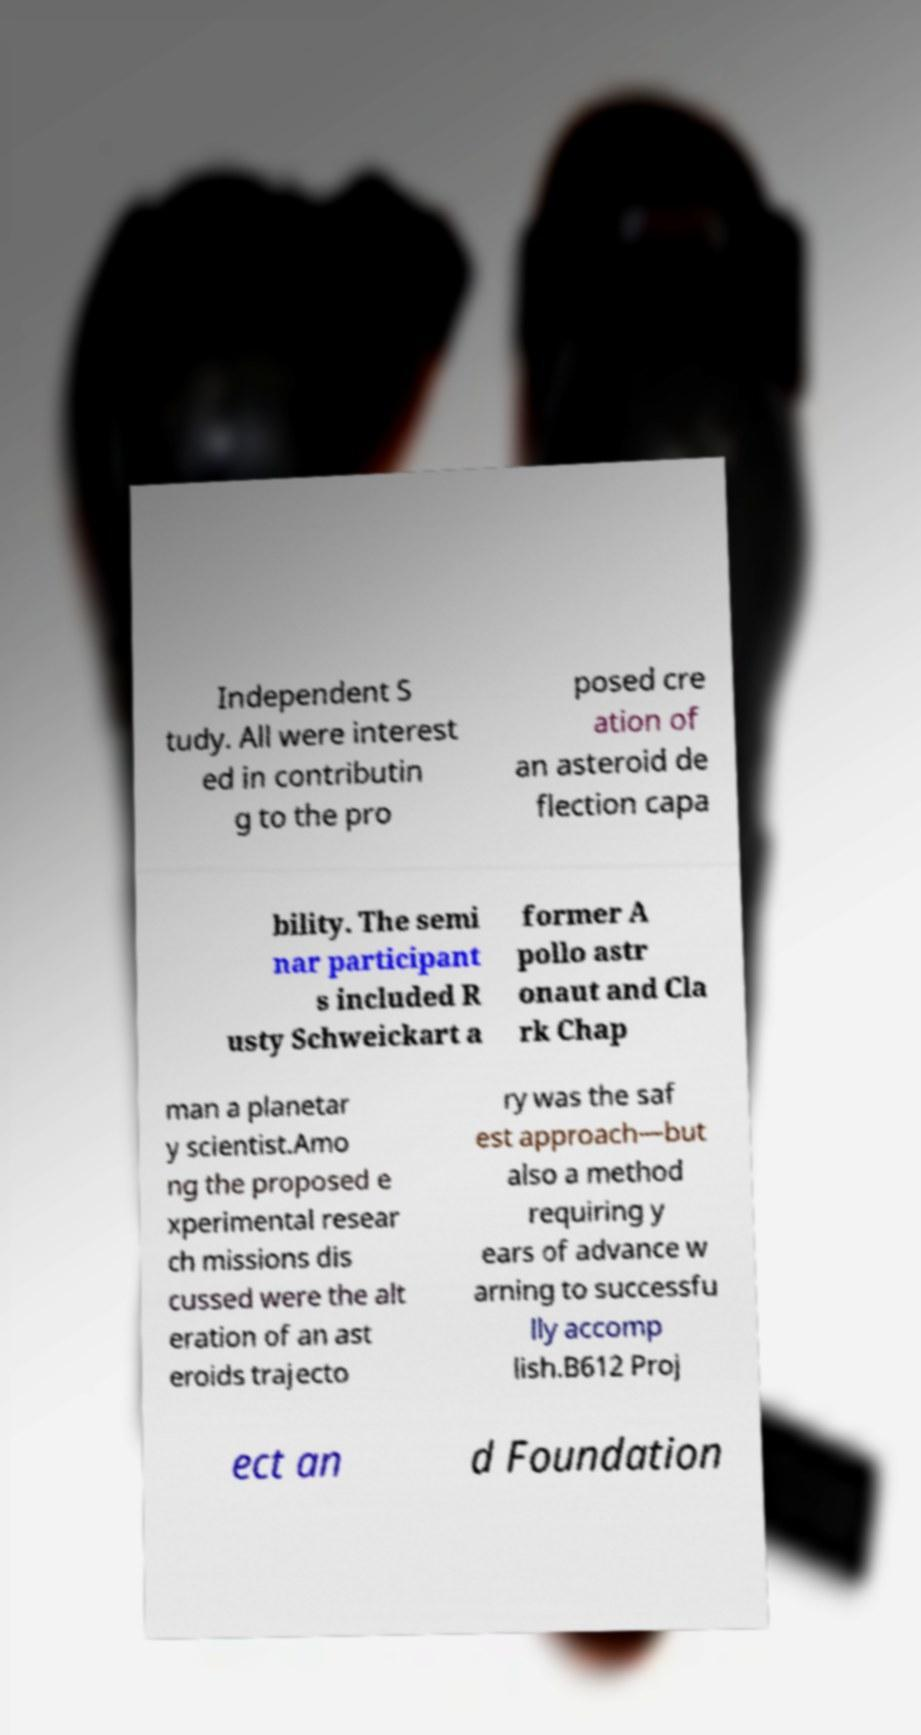Please read and relay the text visible in this image. What does it say? Independent S tudy. All were interest ed in contributin g to the pro posed cre ation of an asteroid de flection capa bility. The semi nar participant s included R usty Schweickart a former A pollo astr onaut and Cla rk Chap man a planetar y scientist.Amo ng the proposed e xperimental resear ch missions dis cussed were the alt eration of an ast eroids trajecto ry was the saf est approach—but also a method requiring y ears of advance w arning to successfu lly accomp lish.B612 Proj ect an d Foundation 